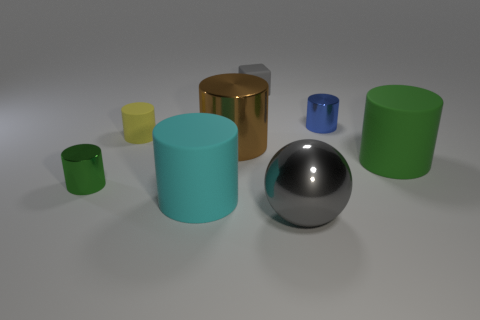How many shiny things are either tiny green things or cyan objects?
Provide a short and direct response. 1. What number of yellow objects are either cylinders or tiny matte cylinders?
Your answer should be compact. 1. There is a small metallic object that is on the left side of the rubber block; does it have the same color as the large shiny ball?
Provide a succinct answer. No. Is the gray cube made of the same material as the blue thing?
Provide a succinct answer. No. Is the number of tiny matte things that are right of the cyan cylinder the same as the number of green matte cylinders in front of the green metal object?
Provide a short and direct response. No. What is the material of the large green thing that is the same shape as the cyan rubber object?
Your answer should be very brief. Rubber. The large metallic object in front of the large matte object that is in front of the rubber cylinder to the right of the small gray matte cube is what shape?
Offer a terse response. Sphere. Are there more small yellow rubber things behind the yellow rubber cylinder than green shiny objects?
Provide a short and direct response. No. Is the shape of the large metal object left of the small gray block the same as  the big gray metallic thing?
Provide a short and direct response. No. There is a green object that is left of the cyan thing; what material is it?
Offer a very short reply. Metal. 